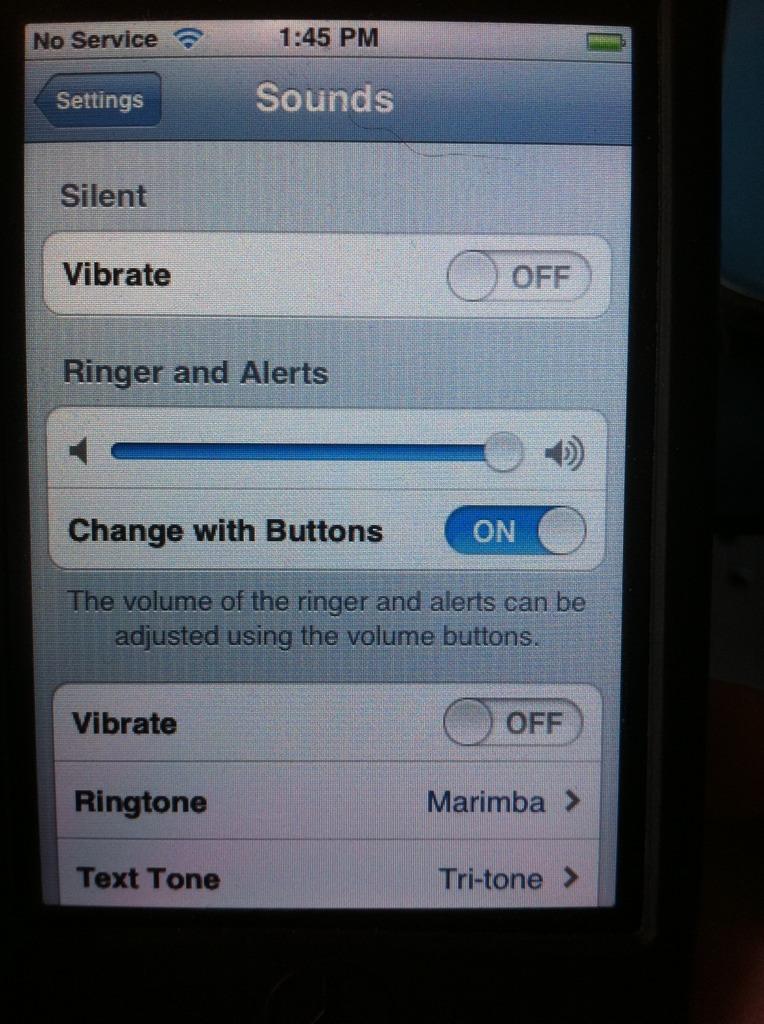What's above the blue slider bar?
Give a very brief answer. Ringer and alerts. What kind of ringtone did they pick?
Give a very brief answer. Marimba. 